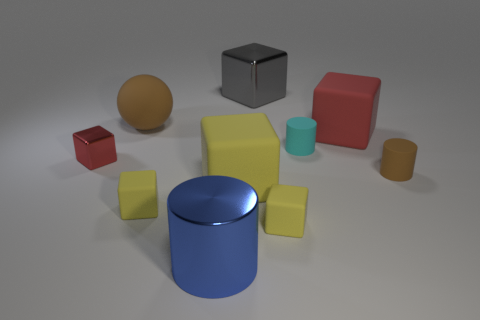Subtract all matte blocks. How many blocks are left? 2 Subtract 3 blocks. How many blocks are left? 3 Subtract all blue cylinders. How many cylinders are left? 2 Subtract all red blocks. How many red cylinders are left? 0 Subtract all big balls. Subtract all gray metal objects. How many objects are left? 8 Add 8 tiny yellow rubber things. How many tiny yellow rubber things are left? 10 Add 3 large purple cylinders. How many large purple cylinders exist? 3 Subtract 0 gray spheres. How many objects are left? 10 Subtract all balls. How many objects are left? 9 Subtract all brown cylinders. Subtract all yellow blocks. How many cylinders are left? 2 